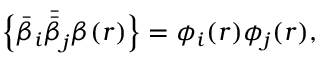Convert formula to latex. <formula><loc_0><loc_0><loc_500><loc_500>\left \{ \bar { \beta } _ { i } \bar { \bar { \beta } } _ { j } \beta ( r ) \right \} = \phi _ { i } ( r ) \phi _ { j } ( r ) ,</formula> 